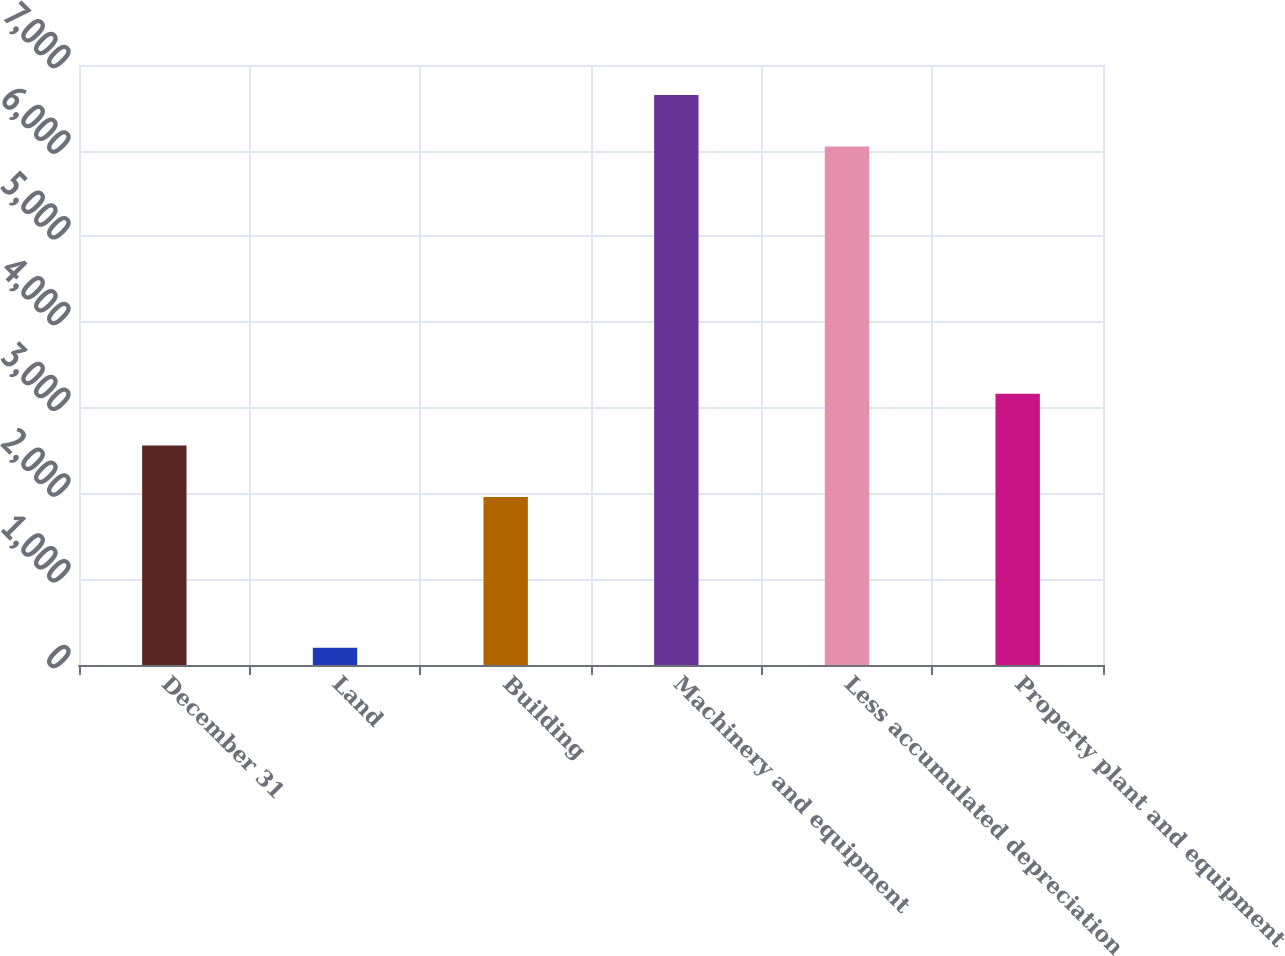Convert chart. <chart><loc_0><loc_0><loc_500><loc_500><bar_chart><fcel>December 31<fcel>Land<fcel>Building<fcel>Machinery and equipment<fcel>Less accumulated depreciation<fcel>Property plant and equipment<nl><fcel>2561.2<fcel>200<fcel>1959<fcel>6651.2<fcel>6049<fcel>3163.4<nl></chart> 